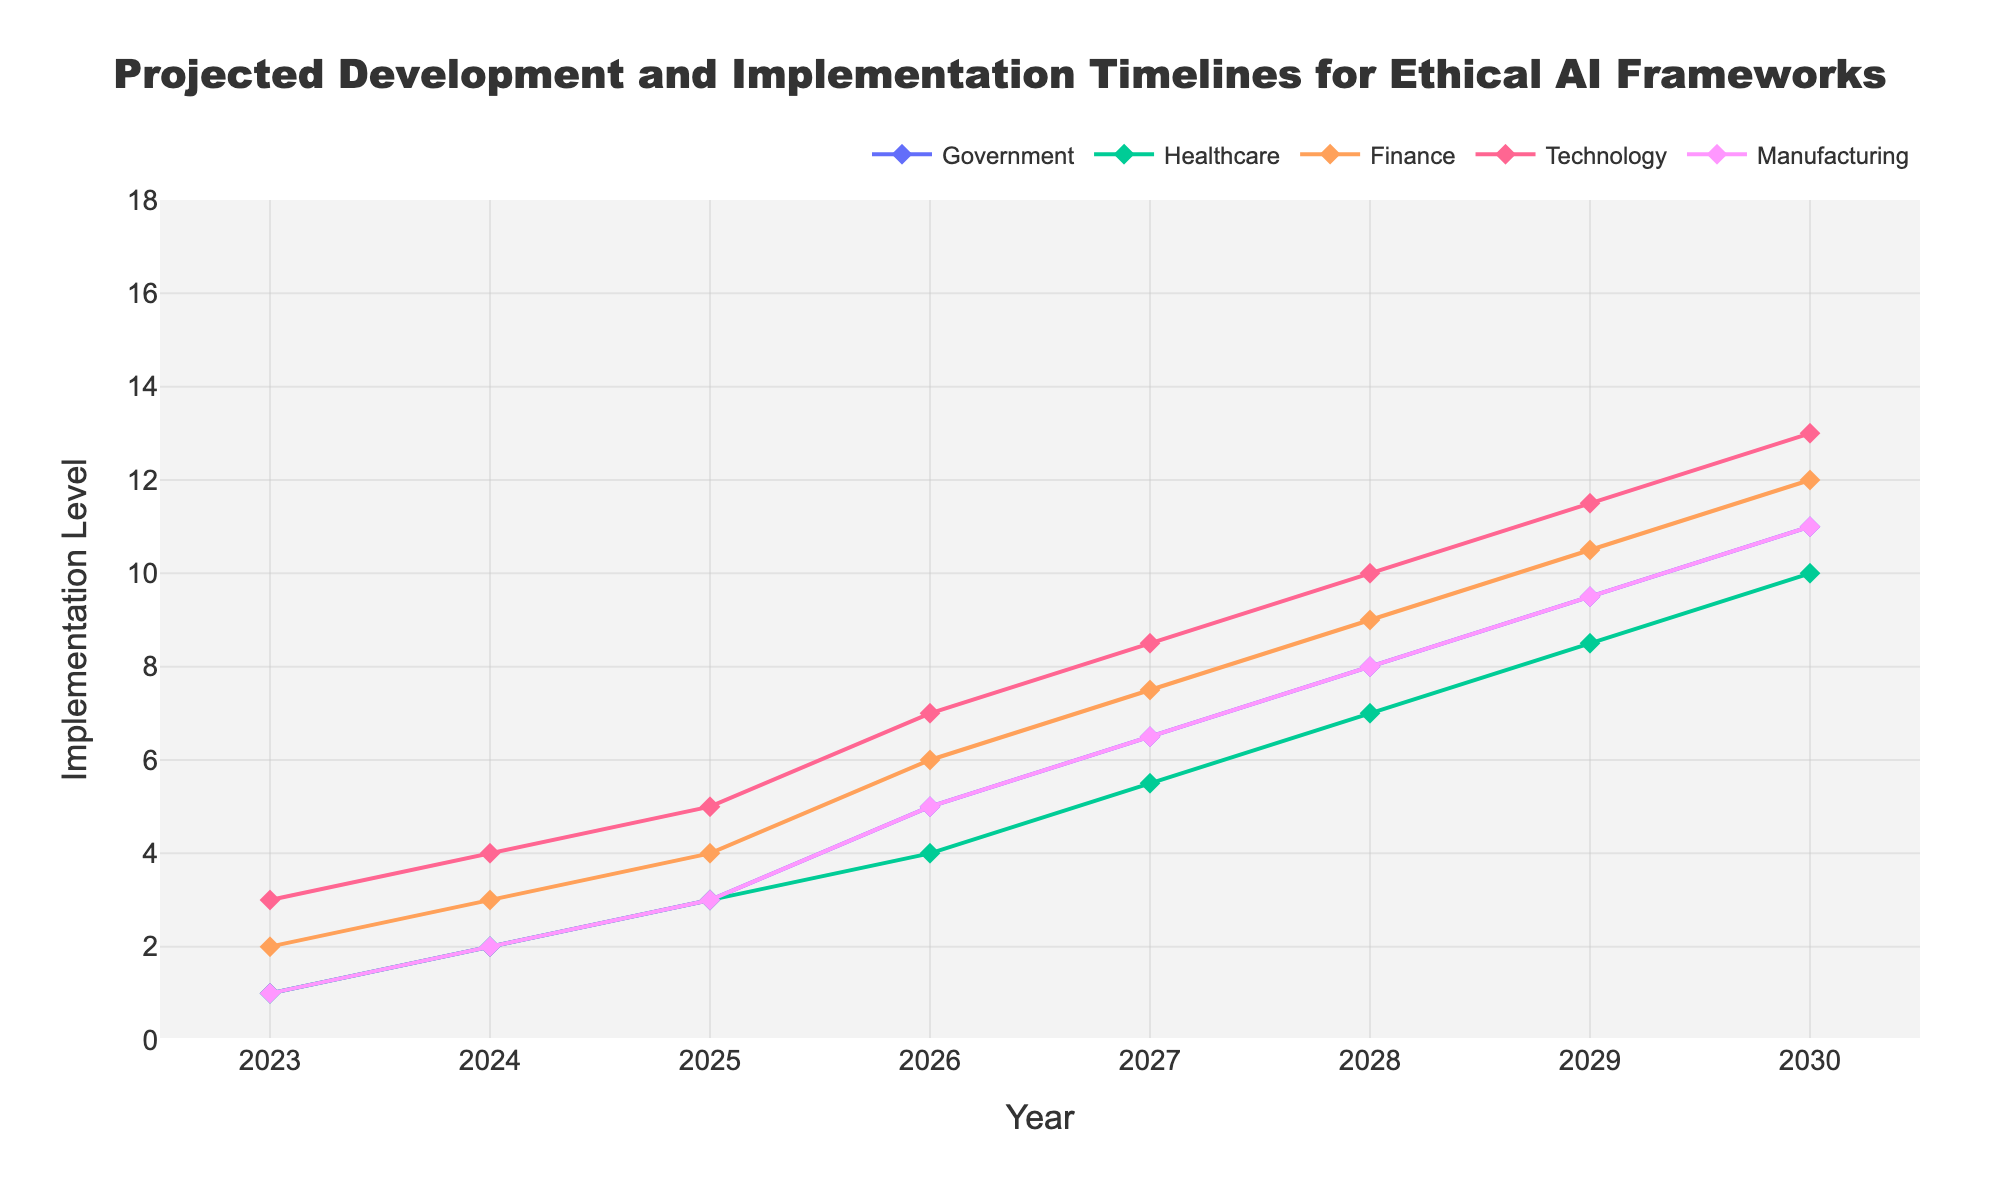What is the title of the chart? The title is displayed at the top of the chart.
Answer: Projected Development and Implementation Timelines for Ethical AI Frameworks How many sectors are analyzed in the chart? The legend indicates the number of sectors being analyzed.
Answer: Five Between which years does the chart provide data? The x-axis at the bottom of the chart shows the range of years covered.
Answer: 2023 to 2030 Which sector has the highest projected implementation level by the year 2025? Look at the y-values for each sector in the year 2025. The Technology sector has the highest value of 5.
Answer: Technology What is the range of implementation levels for the Healthcare sector in the year 2027? Identify the uncertainty band (shade) for the Healthcare sector in 2027.
Answer: 4 to 7 How does the projected implementation level for the Government sector for 2026 compare with that for 2023? Compare the y-values for the Government sector in 2026 and 2023. The value is 4-6 in 2026 and 1 in 2023, showing an increase.
Answer: Higher What is the average of the projected implementation levels for the Finance sector in the years 2028 to 2030? Calculate the average using the values for the Finance sector in 2028 (7-11), 2029 (8-13), and 2030 (9-15). Considering the midpoint of the ranges: (9+10.5+12)/3 = 10.5
Answer: 10.5 By how much does the implementation level for the Technology sector in 2029 exceed that in 2023? Identify the implementation levels for Technology in 2023 (3) and 2029 (9-14), and calculate the difference using the midpoint of the range for 2029: (11.5 - 3) = 8.5
Answer: 8.5 Which sector shows the most significant uncertainty in their projected implementation levels for the year 2030? Determine which sector has the widest uncertainty band/shade for 2030.
Answer: Technology What is the projected implementation level range for Manufacturing in 2026 and 2029? Identify the implementation level range (shaded area) for Manufacturing in the years 2026 and 2029. In 2026: 4-6; in 2029, 7-12.
Answer: 4-6 and 7-12 